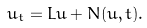Convert formula to latex. <formula><loc_0><loc_0><loc_500><loc_500>u _ { t } = L u + N ( u , t ) .</formula> 